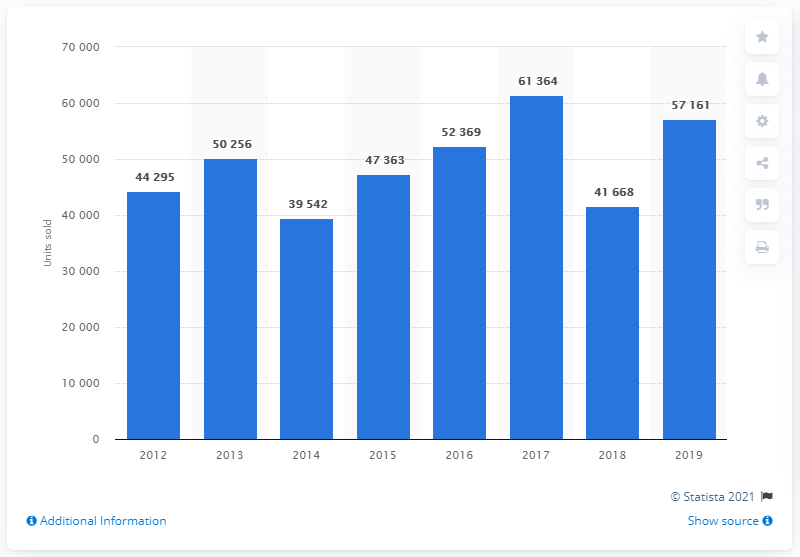Mention a couple of crucial points in this snapshot. In 2017, the highest number of Fiat cars sold in Turkey was 61,364. Fiat sold 57,161 cars in Turkey in 2019. 